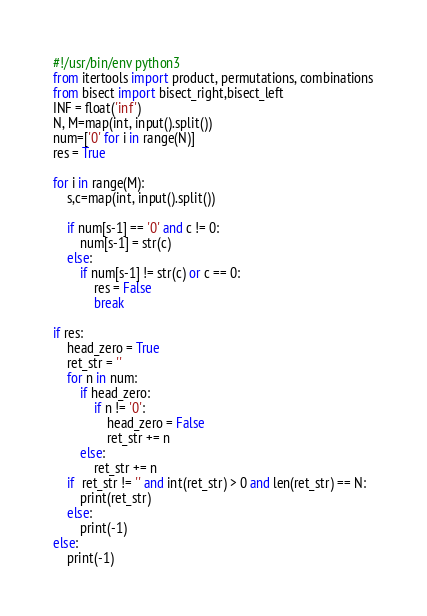<code> <loc_0><loc_0><loc_500><loc_500><_Python_>#!/usr/bin/env python3
from itertools import product, permutations, combinations
from bisect import bisect_right,bisect_left
INF = float('inf')
N, M=map(int, input().split())
num=['0' for i in range(N)]
res = True

for i in range(M):
    s,c=map(int, input().split())

    if num[s-1] == '0' and c != 0:
        num[s-1] = str(c)
    else:
        if num[s-1] != str(c) or c == 0:
            res = False
            break

if res:
    head_zero = True
    ret_str = ''
    for n in num:
        if head_zero:
            if n != '0':
                head_zero = False
                ret_str += n
        else:
            ret_str += n
    if  ret_str != '' and int(ret_str) > 0 and len(ret_str) == N:
        print(ret_str)
    else:
        print(-1)
else:
    print(-1)
</code> 